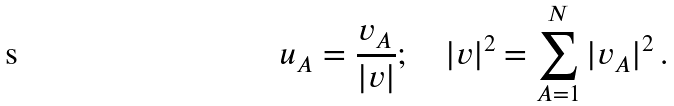<formula> <loc_0><loc_0><loc_500><loc_500>u _ { A } = \frac { v _ { A } } { | v | } ; \quad | v | ^ { 2 } = \sum _ { A = 1 } ^ { N } | v _ { A } | ^ { 2 } \, .</formula> 